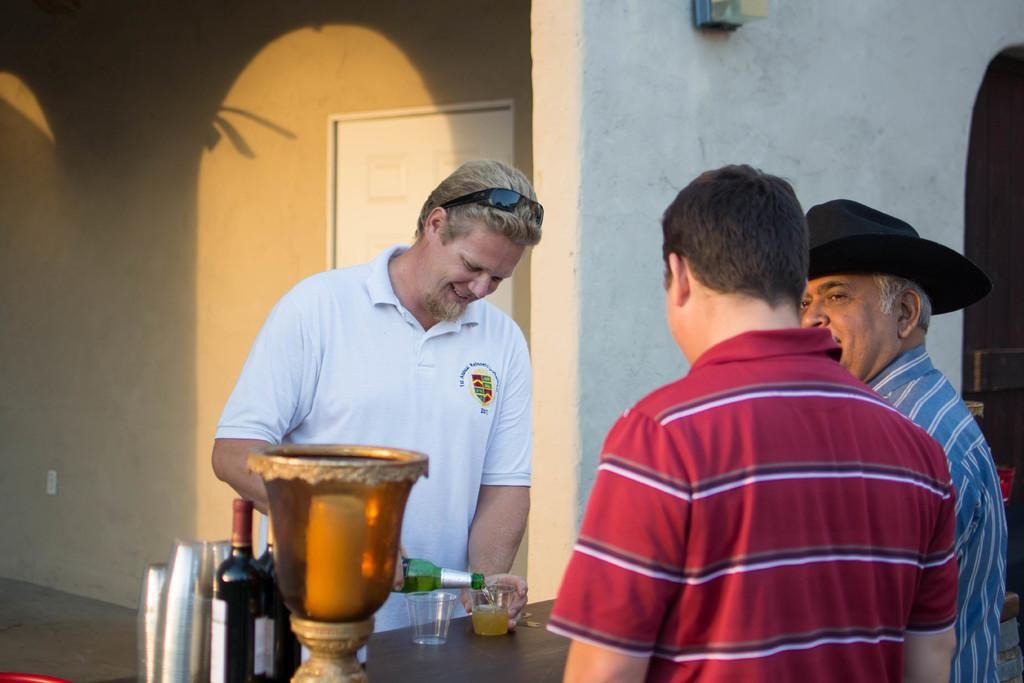What is happening in the image involving the people? There are people standing in the image, and a man is pouring wine into the glasses. What is on the table in the image? There is a table in the image, and on it are wine bottles and glasses. What is the man doing with the wine bottles? The man is pouring wine from the bottles into the glasses. Can you see any sea creatures in the image? There are no sea creatures present in the image; it features people standing around a table with wine bottles and glasses. What type of bait is being used to catch fish in the image? There is no fishing or bait present in the image; it focuses on people pouring wine into glasses. 